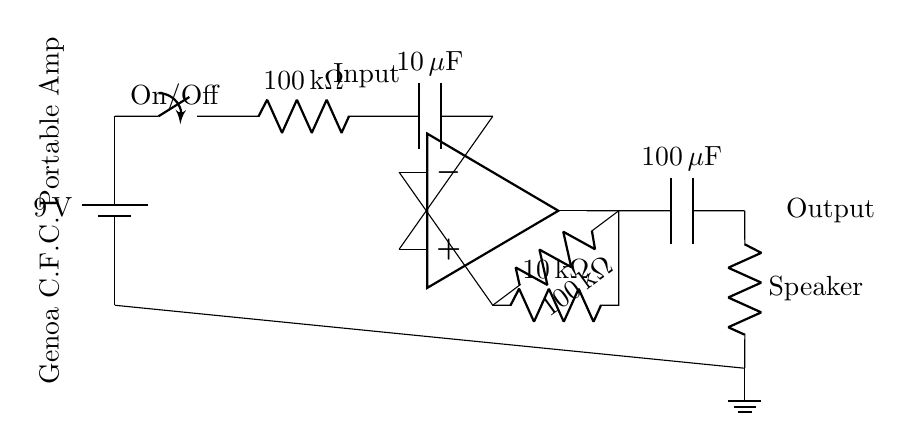What is the power supply voltage? The diagram shows a battery labeled with a voltage of 9 volts in the circuit, indicating the power supply voltage.
Answer: 9 volts What type of switch is used? The circuit has a component labeled as a switch, confirming its function as an on/off control.
Answer: Switch What is the resistance of the input resistor? The input resistor is labeled with a resistance value of 100 kilo-ohms, as indicated in the circuit.
Answer: 100 kilo-ohms What kind of load is connected at the output? The output of the circuit connects to a component labeled as a speaker, indicating that it is the load being driven.
Answer: Speaker What is the value of the output capacitor? The capacitor at the output is labeled with a capacitance of 100 microfarads, providing a clear specification from the diagram.
Answer: 100 microfarads How many resistors are in the feedback loop? There are two resistors connected in the feedback loop of the operational amplifier, one labeled 10 kilo-ohms and the other 100 kilo-ohms.
Answer: Two What is the impedance of the connected speaker? The impedance value of the speaker at the output is specified as 8 ohms in the circuit diagram.
Answer: 8 ohms 